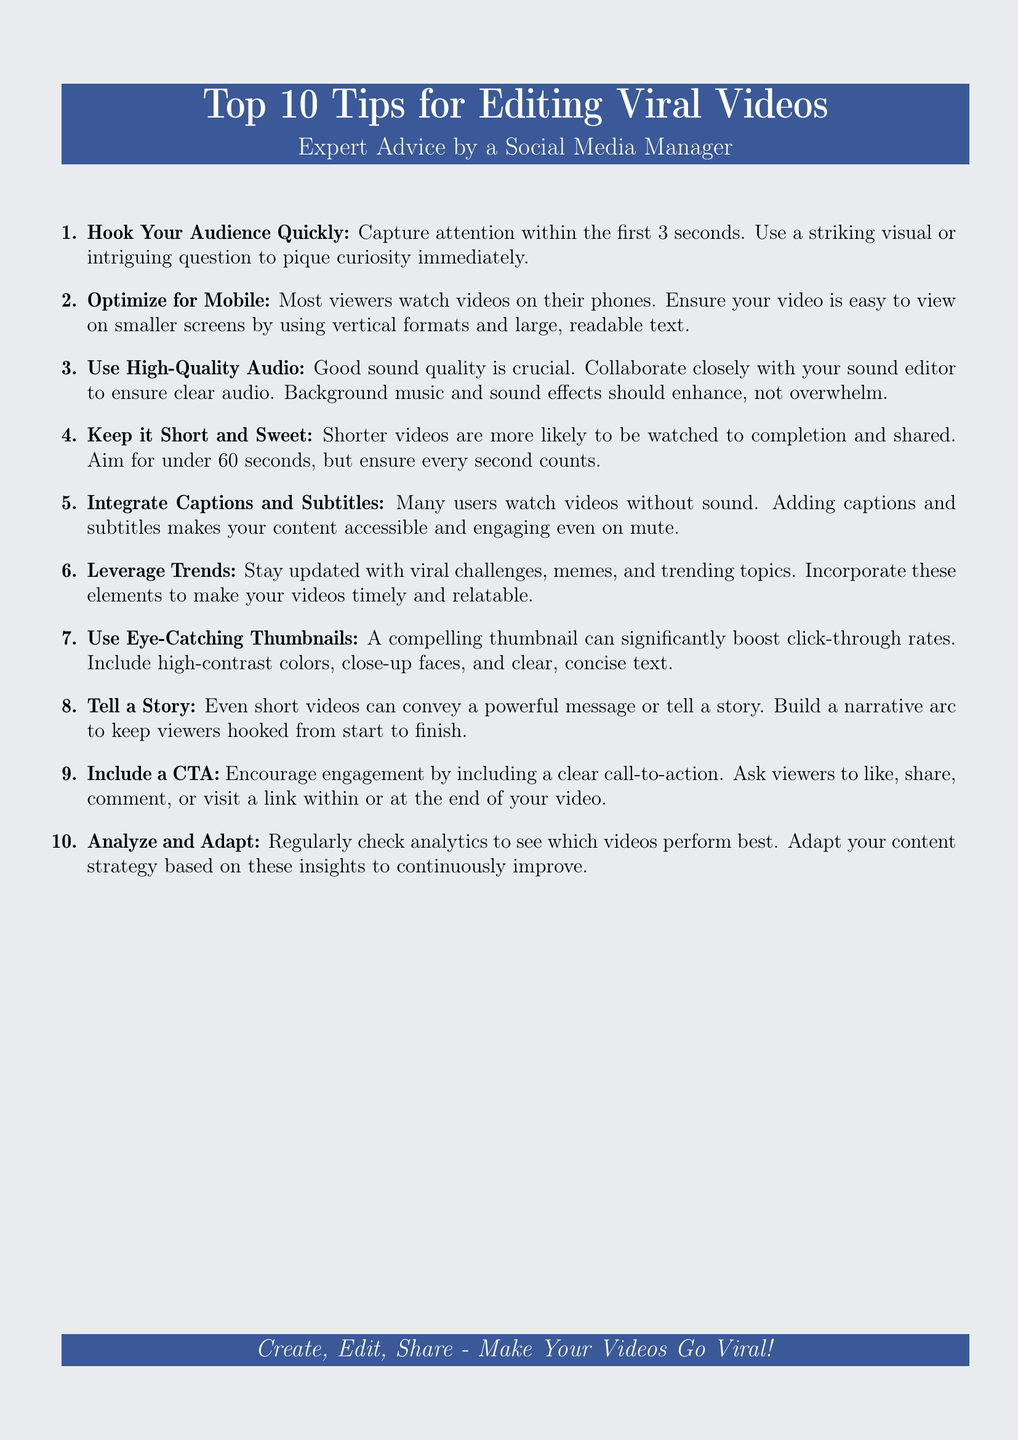What are the top tips for editing viral videos? The document outlines ten specific tips for editing viral videos, starting from quickly hooking the audience to analyzing performance.
Answer: Top 10 Tips What is the recommended video length for maximum engagement? The document suggests keeping videos under a specific time to increase the likelihood of completion and sharing.
Answer: Under 60 seconds What type of audio quality is emphasized in the tips? The importance of audio quality is highlighted, noting the need for clear sound and suitable enhancements.
Answer: High-Quality Audio What should be included to make videos accessible for viewers watching without sound? The document mentions adding a specific element to cater to users who may be viewing videos on mute.
Answer: Captions and Subtitles What visual element can boost click-through rates according to the tips? The document advises on a particular feature that significantly attracts viewers' attention and increases clicks.
Answer: Eye-Catching Thumbnails Which aspect of video creation encourages viewer interaction? A direct suggestion in the document influences how audiences engage with the content after watching.
Answer: Clear Call-to-Action What is the main strategy to enhance video content relevance? Emphasized in the document, this involves keeping up with specific trends within media.
Answer: Leverage Trends Which specific time frame does the document suggest for capturing audience attention? This point discusses the crucial timeframe for engaging an audience right at the beginning.
Answer: First 3 seconds What is the method suggested for story-telling in videos? The document mentions a narrative technique to maintain viewer interest throughout the video.
Answer: Build a narrative arc What should you regularly check to improve video performance? The document highlights a practice necessary for understanding video success and adjusting future content strategies.
Answer: Analytics 